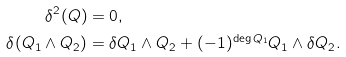<formula> <loc_0><loc_0><loc_500><loc_500>\delta ^ { 2 } ( Q ) & = 0 , \\ \delta ( Q _ { 1 } \wedge Q _ { 2 } ) & = \delta Q _ { 1 } \wedge Q _ { 2 } + ( - 1 ) ^ { \deg Q _ { 1 } } Q _ { 1 } \wedge \delta Q _ { 2 } .</formula> 